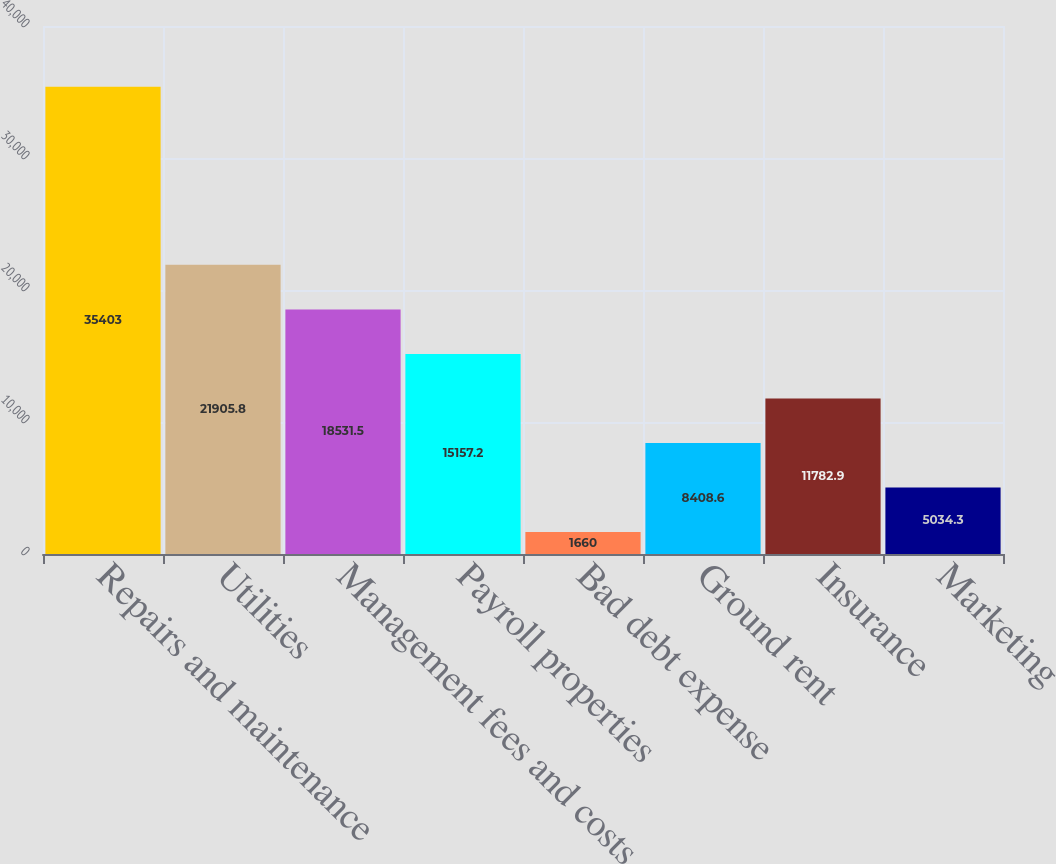<chart> <loc_0><loc_0><loc_500><loc_500><bar_chart><fcel>Repairs and maintenance<fcel>Utilities<fcel>Management fees and costs<fcel>Payroll properties<fcel>Bad debt expense<fcel>Ground rent<fcel>Insurance<fcel>Marketing<nl><fcel>35403<fcel>21905.8<fcel>18531.5<fcel>15157.2<fcel>1660<fcel>8408.6<fcel>11782.9<fcel>5034.3<nl></chart> 